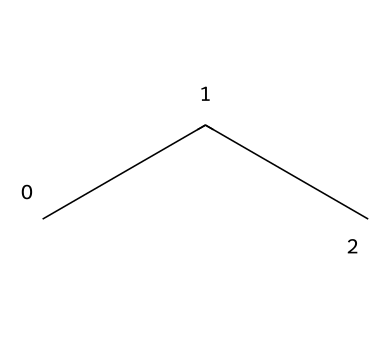What is the molecular formula of propane? Propane, represented by the SMILES 'CCC,' consists of three carbon atoms and eight hydrogen atoms. Therefore, the molecular formula is C3H8.
Answer: C3H8 How many hydrogen atoms are in propane? By examining the structure represented by 'CCC,' we see that there are a total of eight hydrogen atoms attached to the three carbon atoms.
Answer: eight Is propane a saturated or unsaturated hydrocarbon? Propane has only single bonds between the carbon atoms, which indicates that it is a saturated hydrocarbon.
Answer: saturated What type of bonding is present in propane? The chemical structure of propane shows only single bonds between carbon atoms, indicating that the bonding is covalent and specifically characterized as sigma bonding.
Answer: covalent What is the primary use of propane as a refrigerant? Propane is primarily utilized in portable air conditioning units, particularly in scenarios requiring outdoor cooling, such as performances.
Answer: cooling What is the general classification of propane as a refrigerant? Propane is classified as a natural refrigerant due to its origin and properties that make it environmentally friendly compared to synthetic refrigerants.
Answer: natural 